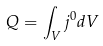Convert formula to latex. <formula><loc_0><loc_0><loc_500><loc_500>Q = \int _ { V } j ^ { 0 } d V</formula> 